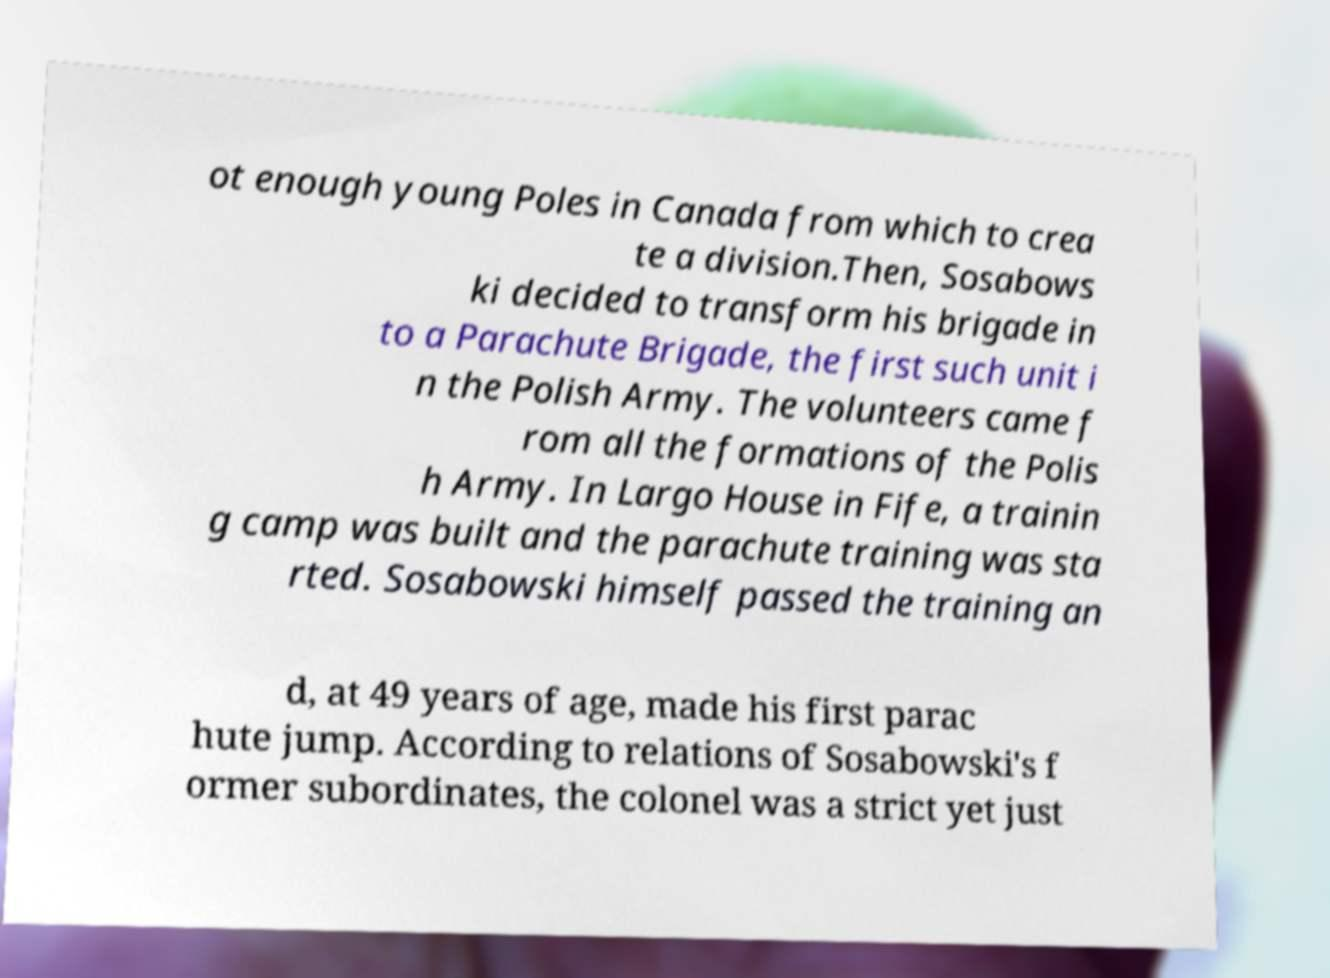Can you accurately transcribe the text from the provided image for me? ot enough young Poles in Canada from which to crea te a division.Then, Sosabows ki decided to transform his brigade in to a Parachute Brigade, the first such unit i n the Polish Army. The volunteers came f rom all the formations of the Polis h Army. In Largo House in Fife, a trainin g camp was built and the parachute training was sta rted. Sosabowski himself passed the training an d, at 49 years of age, made his first parac hute jump. According to relations of Sosabowski's f ormer subordinates, the colonel was a strict yet just 